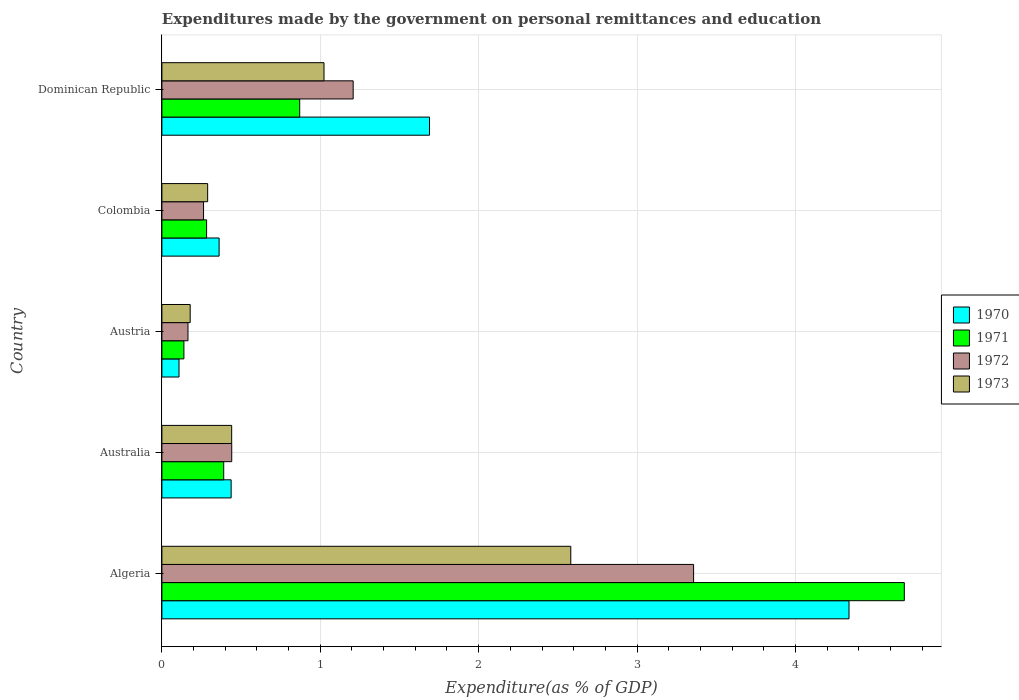How many different coloured bars are there?
Your response must be concise. 4. How many bars are there on the 3rd tick from the top?
Your answer should be very brief. 4. What is the label of the 2nd group of bars from the top?
Offer a terse response. Colombia. What is the expenditures made by the government on personal remittances and education in 1971 in Colombia?
Ensure brevity in your answer.  0.28. Across all countries, what is the maximum expenditures made by the government on personal remittances and education in 1973?
Offer a very short reply. 2.58. Across all countries, what is the minimum expenditures made by the government on personal remittances and education in 1972?
Your answer should be compact. 0.16. In which country was the expenditures made by the government on personal remittances and education in 1973 maximum?
Ensure brevity in your answer.  Algeria. What is the total expenditures made by the government on personal remittances and education in 1970 in the graph?
Make the answer very short. 6.93. What is the difference between the expenditures made by the government on personal remittances and education in 1972 in Colombia and that in Dominican Republic?
Your answer should be compact. -0.94. What is the difference between the expenditures made by the government on personal remittances and education in 1972 in Austria and the expenditures made by the government on personal remittances and education in 1971 in Colombia?
Offer a very short reply. -0.12. What is the average expenditures made by the government on personal remittances and education in 1971 per country?
Provide a succinct answer. 1.27. What is the difference between the expenditures made by the government on personal remittances and education in 1973 and expenditures made by the government on personal remittances and education in 1970 in Dominican Republic?
Provide a short and direct response. -0.67. What is the ratio of the expenditures made by the government on personal remittances and education in 1970 in Algeria to that in Dominican Republic?
Ensure brevity in your answer.  2.57. Is the difference between the expenditures made by the government on personal remittances and education in 1973 in Algeria and Austria greater than the difference between the expenditures made by the government on personal remittances and education in 1970 in Algeria and Austria?
Your answer should be compact. No. What is the difference between the highest and the second highest expenditures made by the government on personal remittances and education in 1972?
Your response must be concise. 2.15. What is the difference between the highest and the lowest expenditures made by the government on personal remittances and education in 1971?
Provide a short and direct response. 4.55. Is the sum of the expenditures made by the government on personal remittances and education in 1972 in Australia and Austria greater than the maximum expenditures made by the government on personal remittances and education in 1973 across all countries?
Offer a very short reply. No. Is it the case that in every country, the sum of the expenditures made by the government on personal remittances and education in 1973 and expenditures made by the government on personal remittances and education in 1970 is greater than the sum of expenditures made by the government on personal remittances and education in 1972 and expenditures made by the government on personal remittances and education in 1971?
Provide a short and direct response. No. What does the 3rd bar from the top in Algeria represents?
Provide a short and direct response. 1971. Are all the bars in the graph horizontal?
Offer a terse response. Yes. What is the difference between two consecutive major ticks on the X-axis?
Offer a very short reply. 1. Are the values on the major ticks of X-axis written in scientific E-notation?
Give a very brief answer. No. Does the graph contain grids?
Your answer should be very brief. Yes. How are the legend labels stacked?
Provide a short and direct response. Vertical. What is the title of the graph?
Keep it short and to the point. Expenditures made by the government on personal remittances and education. What is the label or title of the X-axis?
Provide a short and direct response. Expenditure(as % of GDP). What is the Expenditure(as % of GDP) in 1970 in Algeria?
Your response must be concise. 4.34. What is the Expenditure(as % of GDP) of 1971 in Algeria?
Your answer should be very brief. 4.69. What is the Expenditure(as % of GDP) in 1972 in Algeria?
Provide a short and direct response. 3.36. What is the Expenditure(as % of GDP) in 1973 in Algeria?
Provide a succinct answer. 2.58. What is the Expenditure(as % of GDP) of 1970 in Australia?
Provide a short and direct response. 0.44. What is the Expenditure(as % of GDP) of 1971 in Australia?
Give a very brief answer. 0.39. What is the Expenditure(as % of GDP) of 1972 in Australia?
Keep it short and to the point. 0.44. What is the Expenditure(as % of GDP) of 1973 in Australia?
Provide a succinct answer. 0.44. What is the Expenditure(as % of GDP) in 1970 in Austria?
Offer a very short reply. 0.11. What is the Expenditure(as % of GDP) in 1971 in Austria?
Ensure brevity in your answer.  0.14. What is the Expenditure(as % of GDP) of 1972 in Austria?
Offer a terse response. 0.16. What is the Expenditure(as % of GDP) of 1973 in Austria?
Keep it short and to the point. 0.18. What is the Expenditure(as % of GDP) of 1970 in Colombia?
Keep it short and to the point. 0.36. What is the Expenditure(as % of GDP) of 1971 in Colombia?
Offer a terse response. 0.28. What is the Expenditure(as % of GDP) of 1972 in Colombia?
Your answer should be very brief. 0.26. What is the Expenditure(as % of GDP) in 1973 in Colombia?
Offer a very short reply. 0.29. What is the Expenditure(as % of GDP) of 1970 in Dominican Republic?
Your answer should be compact. 1.69. What is the Expenditure(as % of GDP) of 1971 in Dominican Republic?
Keep it short and to the point. 0.87. What is the Expenditure(as % of GDP) in 1972 in Dominican Republic?
Make the answer very short. 1.21. What is the Expenditure(as % of GDP) in 1973 in Dominican Republic?
Keep it short and to the point. 1.02. Across all countries, what is the maximum Expenditure(as % of GDP) of 1970?
Provide a succinct answer. 4.34. Across all countries, what is the maximum Expenditure(as % of GDP) of 1971?
Keep it short and to the point. 4.69. Across all countries, what is the maximum Expenditure(as % of GDP) in 1972?
Make the answer very short. 3.36. Across all countries, what is the maximum Expenditure(as % of GDP) of 1973?
Offer a terse response. 2.58. Across all countries, what is the minimum Expenditure(as % of GDP) in 1970?
Keep it short and to the point. 0.11. Across all countries, what is the minimum Expenditure(as % of GDP) of 1971?
Offer a terse response. 0.14. Across all countries, what is the minimum Expenditure(as % of GDP) in 1972?
Offer a very short reply. 0.16. Across all countries, what is the minimum Expenditure(as % of GDP) of 1973?
Offer a terse response. 0.18. What is the total Expenditure(as % of GDP) in 1970 in the graph?
Provide a succinct answer. 6.93. What is the total Expenditure(as % of GDP) in 1971 in the graph?
Ensure brevity in your answer.  6.37. What is the total Expenditure(as % of GDP) in 1972 in the graph?
Give a very brief answer. 5.43. What is the total Expenditure(as % of GDP) of 1973 in the graph?
Your answer should be compact. 4.51. What is the difference between the Expenditure(as % of GDP) of 1970 in Algeria and that in Australia?
Give a very brief answer. 3.9. What is the difference between the Expenditure(as % of GDP) in 1971 in Algeria and that in Australia?
Provide a short and direct response. 4.3. What is the difference between the Expenditure(as % of GDP) in 1972 in Algeria and that in Australia?
Give a very brief answer. 2.92. What is the difference between the Expenditure(as % of GDP) in 1973 in Algeria and that in Australia?
Provide a succinct answer. 2.14. What is the difference between the Expenditure(as % of GDP) of 1970 in Algeria and that in Austria?
Your answer should be compact. 4.23. What is the difference between the Expenditure(as % of GDP) of 1971 in Algeria and that in Austria?
Ensure brevity in your answer.  4.55. What is the difference between the Expenditure(as % of GDP) in 1972 in Algeria and that in Austria?
Your response must be concise. 3.19. What is the difference between the Expenditure(as % of GDP) of 1973 in Algeria and that in Austria?
Provide a succinct answer. 2.4. What is the difference between the Expenditure(as % of GDP) in 1970 in Algeria and that in Colombia?
Give a very brief answer. 3.98. What is the difference between the Expenditure(as % of GDP) in 1971 in Algeria and that in Colombia?
Your response must be concise. 4.41. What is the difference between the Expenditure(as % of GDP) in 1972 in Algeria and that in Colombia?
Offer a very short reply. 3.09. What is the difference between the Expenditure(as % of GDP) of 1973 in Algeria and that in Colombia?
Offer a very short reply. 2.29. What is the difference between the Expenditure(as % of GDP) in 1970 in Algeria and that in Dominican Republic?
Your answer should be very brief. 2.65. What is the difference between the Expenditure(as % of GDP) of 1971 in Algeria and that in Dominican Republic?
Your response must be concise. 3.82. What is the difference between the Expenditure(as % of GDP) in 1972 in Algeria and that in Dominican Republic?
Keep it short and to the point. 2.15. What is the difference between the Expenditure(as % of GDP) of 1973 in Algeria and that in Dominican Republic?
Your answer should be very brief. 1.56. What is the difference between the Expenditure(as % of GDP) of 1970 in Australia and that in Austria?
Make the answer very short. 0.33. What is the difference between the Expenditure(as % of GDP) in 1971 in Australia and that in Austria?
Offer a very short reply. 0.25. What is the difference between the Expenditure(as % of GDP) in 1972 in Australia and that in Austria?
Your response must be concise. 0.28. What is the difference between the Expenditure(as % of GDP) of 1973 in Australia and that in Austria?
Give a very brief answer. 0.26. What is the difference between the Expenditure(as % of GDP) of 1970 in Australia and that in Colombia?
Give a very brief answer. 0.08. What is the difference between the Expenditure(as % of GDP) in 1971 in Australia and that in Colombia?
Provide a succinct answer. 0.11. What is the difference between the Expenditure(as % of GDP) of 1972 in Australia and that in Colombia?
Your response must be concise. 0.18. What is the difference between the Expenditure(as % of GDP) of 1973 in Australia and that in Colombia?
Your answer should be very brief. 0.15. What is the difference between the Expenditure(as % of GDP) of 1970 in Australia and that in Dominican Republic?
Your answer should be very brief. -1.25. What is the difference between the Expenditure(as % of GDP) in 1971 in Australia and that in Dominican Republic?
Give a very brief answer. -0.48. What is the difference between the Expenditure(as % of GDP) of 1972 in Australia and that in Dominican Republic?
Make the answer very short. -0.77. What is the difference between the Expenditure(as % of GDP) of 1973 in Australia and that in Dominican Republic?
Make the answer very short. -0.58. What is the difference between the Expenditure(as % of GDP) in 1970 in Austria and that in Colombia?
Offer a very short reply. -0.25. What is the difference between the Expenditure(as % of GDP) in 1971 in Austria and that in Colombia?
Give a very brief answer. -0.14. What is the difference between the Expenditure(as % of GDP) in 1972 in Austria and that in Colombia?
Your response must be concise. -0.1. What is the difference between the Expenditure(as % of GDP) in 1973 in Austria and that in Colombia?
Offer a very short reply. -0.11. What is the difference between the Expenditure(as % of GDP) of 1970 in Austria and that in Dominican Republic?
Make the answer very short. -1.58. What is the difference between the Expenditure(as % of GDP) in 1971 in Austria and that in Dominican Republic?
Offer a very short reply. -0.73. What is the difference between the Expenditure(as % of GDP) of 1972 in Austria and that in Dominican Republic?
Offer a very short reply. -1.04. What is the difference between the Expenditure(as % of GDP) in 1973 in Austria and that in Dominican Republic?
Offer a very short reply. -0.84. What is the difference between the Expenditure(as % of GDP) of 1970 in Colombia and that in Dominican Republic?
Ensure brevity in your answer.  -1.33. What is the difference between the Expenditure(as % of GDP) of 1971 in Colombia and that in Dominican Republic?
Offer a very short reply. -0.59. What is the difference between the Expenditure(as % of GDP) of 1972 in Colombia and that in Dominican Republic?
Offer a very short reply. -0.94. What is the difference between the Expenditure(as % of GDP) of 1973 in Colombia and that in Dominican Republic?
Your answer should be compact. -0.73. What is the difference between the Expenditure(as % of GDP) in 1970 in Algeria and the Expenditure(as % of GDP) in 1971 in Australia?
Provide a short and direct response. 3.95. What is the difference between the Expenditure(as % of GDP) of 1970 in Algeria and the Expenditure(as % of GDP) of 1972 in Australia?
Provide a succinct answer. 3.9. What is the difference between the Expenditure(as % of GDP) of 1970 in Algeria and the Expenditure(as % of GDP) of 1973 in Australia?
Keep it short and to the point. 3.9. What is the difference between the Expenditure(as % of GDP) of 1971 in Algeria and the Expenditure(as % of GDP) of 1972 in Australia?
Your answer should be very brief. 4.25. What is the difference between the Expenditure(as % of GDP) in 1971 in Algeria and the Expenditure(as % of GDP) in 1973 in Australia?
Your answer should be very brief. 4.25. What is the difference between the Expenditure(as % of GDP) of 1972 in Algeria and the Expenditure(as % of GDP) of 1973 in Australia?
Offer a very short reply. 2.92. What is the difference between the Expenditure(as % of GDP) of 1970 in Algeria and the Expenditure(as % of GDP) of 1971 in Austria?
Keep it short and to the point. 4.2. What is the difference between the Expenditure(as % of GDP) in 1970 in Algeria and the Expenditure(as % of GDP) in 1972 in Austria?
Your answer should be very brief. 4.17. What is the difference between the Expenditure(as % of GDP) in 1970 in Algeria and the Expenditure(as % of GDP) in 1973 in Austria?
Provide a succinct answer. 4.16. What is the difference between the Expenditure(as % of GDP) of 1971 in Algeria and the Expenditure(as % of GDP) of 1972 in Austria?
Make the answer very short. 4.52. What is the difference between the Expenditure(as % of GDP) of 1971 in Algeria and the Expenditure(as % of GDP) of 1973 in Austria?
Provide a short and direct response. 4.51. What is the difference between the Expenditure(as % of GDP) in 1972 in Algeria and the Expenditure(as % of GDP) in 1973 in Austria?
Your answer should be very brief. 3.18. What is the difference between the Expenditure(as % of GDP) of 1970 in Algeria and the Expenditure(as % of GDP) of 1971 in Colombia?
Ensure brevity in your answer.  4.06. What is the difference between the Expenditure(as % of GDP) of 1970 in Algeria and the Expenditure(as % of GDP) of 1972 in Colombia?
Your answer should be very brief. 4.08. What is the difference between the Expenditure(as % of GDP) of 1970 in Algeria and the Expenditure(as % of GDP) of 1973 in Colombia?
Ensure brevity in your answer.  4.05. What is the difference between the Expenditure(as % of GDP) in 1971 in Algeria and the Expenditure(as % of GDP) in 1972 in Colombia?
Offer a terse response. 4.42. What is the difference between the Expenditure(as % of GDP) of 1971 in Algeria and the Expenditure(as % of GDP) of 1973 in Colombia?
Your answer should be compact. 4.4. What is the difference between the Expenditure(as % of GDP) in 1972 in Algeria and the Expenditure(as % of GDP) in 1973 in Colombia?
Offer a very short reply. 3.07. What is the difference between the Expenditure(as % of GDP) in 1970 in Algeria and the Expenditure(as % of GDP) in 1971 in Dominican Republic?
Your answer should be compact. 3.47. What is the difference between the Expenditure(as % of GDP) in 1970 in Algeria and the Expenditure(as % of GDP) in 1972 in Dominican Republic?
Your response must be concise. 3.13. What is the difference between the Expenditure(as % of GDP) in 1970 in Algeria and the Expenditure(as % of GDP) in 1973 in Dominican Republic?
Keep it short and to the point. 3.31. What is the difference between the Expenditure(as % of GDP) in 1971 in Algeria and the Expenditure(as % of GDP) in 1972 in Dominican Republic?
Provide a short and direct response. 3.48. What is the difference between the Expenditure(as % of GDP) in 1971 in Algeria and the Expenditure(as % of GDP) in 1973 in Dominican Republic?
Make the answer very short. 3.66. What is the difference between the Expenditure(as % of GDP) of 1972 in Algeria and the Expenditure(as % of GDP) of 1973 in Dominican Republic?
Provide a succinct answer. 2.33. What is the difference between the Expenditure(as % of GDP) of 1970 in Australia and the Expenditure(as % of GDP) of 1971 in Austria?
Ensure brevity in your answer.  0.3. What is the difference between the Expenditure(as % of GDP) in 1970 in Australia and the Expenditure(as % of GDP) in 1972 in Austria?
Offer a terse response. 0.27. What is the difference between the Expenditure(as % of GDP) in 1970 in Australia and the Expenditure(as % of GDP) in 1973 in Austria?
Provide a short and direct response. 0.26. What is the difference between the Expenditure(as % of GDP) of 1971 in Australia and the Expenditure(as % of GDP) of 1972 in Austria?
Ensure brevity in your answer.  0.23. What is the difference between the Expenditure(as % of GDP) of 1971 in Australia and the Expenditure(as % of GDP) of 1973 in Austria?
Provide a short and direct response. 0.21. What is the difference between the Expenditure(as % of GDP) of 1972 in Australia and the Expenditure(as % of GDP) of 1973 in Austria?
Provide a succinct answer. 0.26. What is the difference between the Expenditure(as % of GDP) of 1970 in Australia and the Expenditure(as % of GDP) of 1971 in Colombia?
Your answer should be very brief. 0.15. What is the difference between the Expenditure(as % of GDP) of 1970 in Australia and the Expenditure(as % of GDP) of 1972 in Colombia?
Make the answer very short. 0.17. What is the difference between the Expenditure(as % of GDP) of 1970 in Australia and the Expenditure(as % of GDP) of 1973 in Colombia?
Make the answer very short. 0.15. What is the difference between the Expenditure(as % of GDP) in 1971 in Australia and the Expenditure(as % of GDP) in 1972 in Colombia?
Make the answer very short. 0.13. What is the difference between the Expenditure(as % of GDP) in 1971 in Australia and the Expenditure(as % of GDP) in 1973 in Colombia?
Make the answer very short. 0.1. What is the difference between the Expenditure(as % of GDP) of 1972 in Australia and the Expenditure(as % of GDP) of 1973 in Colombia?
Your answer should be compact. 0.15. What is the difference between the Expenditure(as % of GDP) of 1970 in Australia and the Expenditure(as % of GDP) of 1971 in Dominican Republic?
Provide a succinct answer. -0.43. What is the difference between the Expenditure(as % of GDP) in 1970 in Australia and the Expenditure(as % of GDP) in 1972 in Dominican Republic?
Offer a very short reply. -0.77. What is the difference between the Expenditure(as % of GDP) in 1970 in Australia and the Expenditure(as % of GDP) in 1973 in Dominican Republic?
Your answer should be very brief. -0.59. What is the difference between the Expenditure(as % of GDP) in 1971 in Australia and the Expenditure(as % of GDP) in 1972 in Dominican Republic?
Make the answer very short. -0.82. What is the difference between the Expenditure(as % of GDP) in 1971 in Australia and the Expenditure(as % of GDP) in 1973 in Dominican Republic?
Your answer should be compact. -0.63. What is the difference between the Expenditure(as % of GDP) of 1972 in Australia and the Expenditure(as % of GDP) of 1973 in Dominican Republic?
Offer a terse response. -0.58. What is the difference between the Expenditure(as % of GDP) in 1970 in Austria and the Expenditure(as % of GDP) in 1971 in Colombia?
Give a very brief answer. -0.17. What is the difference between the Expenditure(as % of GDP) of 1970 in Austria and the Expenditure(as % of GDP) of 1972 in Colombia?
Your response must be concise. -0.15. What is the difference between the Expenditure(as % of GDP) in 1970 in Austria and the Expenditure(as % of GDP) in 1973 in Colombia?
Provide a succinct answer. -0.18. What is the difference between the Expenditure(as % of GDP) in 1971 in Austria and the Expenditure(as % of GDP) in 1972 in Colombia?
Ensure brevity in your answer.  -0.12. What is the difference between the Expenditure(as % of GDP) of 1971 in Austria and the Expenditure(as % of GDP) of 1973 in Colombia?
Offer a very short reply. -0.15. What is the difference between the Expenditure(as % of GDP) of 1972 in Austria and the Expenditure(as % of GDP) of 1973 in Colombia?
Keep it short and to the point. -0.12. What is the difference between the Expenditure(as % of GDP) in 1970 in Austria and the Expenditure(as % of GDP) in 1971 in Dominican Republic?
Provide a short and direct response. -0.76. What is the difference between the Expenditure(as % of GDP) of 1970 in Austria and the Expenditure(as % of GDP) of 1972 in Dominican Republic?
Ensure brevity in your answer.  -1.1. What is the difference between the Expenditure(as % of GDP) in 1970 in Austria and the Expenditure(as % of GDP) in 1973 in Dominican Republic?
Make the answer very short. -0.92. What is the difference between the Expenditure(as % of GDP) of 1971 in Austria and the Expenditure(as % of GDP) of 1972 in Dominican Republic?
Your answer should be compact. -1.07. What is the difference between the Expenditure(as % of GDP) of 1971 in Austria and the Expenditure(as % of GDP) of 1973 in Dominican Republic?
Ensure brevity in your answer.  -0.88. What is the difference between the Expenditure(as % of GDP) in 1972 in Austria and the Expenditure(as % of GDP) in 1973 in Dominican Republic?
Offer a very short reply. -0.86. What is the difference between the Expenditure(as % of GDP) in 1970 in Colombia and the Expenditure(as % of GDP) in 1971 in Dominican Republic?
Ensure brevity in your answer.  -0.51. What is the difference between the Expenditure(as % of GDP) of 1970 in Colombia and the Expenditure(as % of GDP) of 1972 in Dominican Republic?
Your answer should be very brief. -0.85. What is the difference between the Expenditure(as % of GDP) in 1970 in Colombia and the Expenditure(as % of GDP) in 1973 in Dominican Republic?
Keep it short and to the point. -0.66. What is the difference between the Expenditure(as % of GDP) of 1971 in Colombia and the Expenditure(as % of GDP) of 1972 in Dominican Republic?
Make the answer very short. -0.93. What is the difference between the Expenditure(as % of GDP) in 1971 in Colombia and the Expenditure(as % of GDP) in 1973 in Dominican Republic?
Make the answer very short. -0.74. What is the difference between the Expenditure(as % of GDP) in 1972 in Colombia and the Expenditure(as % of GDP) in 1973 in Dominican Republic?
Provide a succinct answer. -0.76. What is the average Expenditure(as % of GDP) in 1970 per country?
Provide a short and direct response. 1.39. What is the average Expenditure(as % of GDP) in 1971 per country?
Offer a terse response. 1.27. What is the average Expenditure(as % of GDP) in 1972 per country?
Your response must be concise. 1.09. What is the average Expenditure(as % of GDP) of 1973 per country?
Offer a terse response. 0.9. What is the difference between the Expenditure(as % of GDP) in 1970 and Expenditure(as % of GDP) in 1971 in Algeria?
Offer a very short reply. -0.35. What is the difference between the Expenditure(as % of GDP) in 1970 and Expenditure(as % of GDP) in 1972 in Algeria?
Provide a short and direct response. 0.98. What is the difference between the Expenditure(as % of GDP) of 1970 and Expenditure(as % of GDP) of 1973 in Algeria?
Ensure brevity in your answer.  1.76. What is the difference between the Expenditure(as % of GDP) in 1971 and Expenditure(as % of GDP) in 1972 in Algeria?
Ensure brevity in your answer.  1.33. What is the difference between the Expenditure(as % of GDP) of 1971 and Expenditure(as % of GDP) of 1973 in Algeria?
Ensure brevity in your answer.  2.11. What is the difference between the Expenditure(as % of GDP) in 1972 and Expenditure(as % of GDP) in 1973 in Algeria?
Provide a short and direct response. 0.78. What is the difference between the Expenditure(as % of GDP) of 1970 and Expenditure(as % of GDP) of 1971 in Australia?
Your response must be concise. 0.05. What is the difference between the Expenditure(as % of GDP) in 1970 and Expenditure(as % of GDP) in 1972 in Australia?
Keep it short and to the point. -0. What is the difference between the Expenditure(as % of GDP) in 1970 and Expenditure(as % of GDP) in 1973 in Australia?
Offer a very short reply. -0. What is the difference between the Expenditure(as % of GDP) in 1971 and Expenditure(as % of GDP) in 1972 in Australia?
Provide a succinct answer. -0.05. What is the difference between the Expenditure(as % of GDP) in 1971 and Expenditure(as % of GDP) in 1973 in Australia?
Keep it short and to the point. -0.05. What is the difference between the Expenditure(as % of GDP) in 1972 and Expenditure(as % of GDP) in 1973 in Australia?
Give a very brief answer. 0. What is the difference between the Expenditure(as % of GDP) in 1970 and Expenditure(as % of GDP) in 1971 in Austria?
Ensure brevity in your answer.  -0.03. What is the difference between the Expenditure(as % of GDP) in 1970 and Expenditure(as % of GDP) in 1972 in Austria?
Ensure brevity in your answer.  -0.06. What is the difference between the Expenditure(as % of GDP) in 1970 and Expenditure(as % of GDP) in 1973 in Austria?
Provide a succinct answer. -0.07. What is the difference between the Expenditure(as % of GDP) in 1971 and Expenditure(as % of GDP) in 1972 in Austria?
Keep it short and to the point. -0.03. What is the difference between the Expenditure(as % of GDP) of 1971 and Expenditure(as % of GDP) of 1973 in Austria?
Make the answer very short. -0.04. What is the difference between the Expenditure(as % of GDP) in 1972 and Expenditure(as % of GDP) in 1973 in Austria?
Ensure brevity in your answer.  -0.01. What is the difference between the Expenditure(as % of GDP) in 1970 and Expenditure(as % of GDP) in 1971 in Colombia?
Your answer should be compact. 0.08. What is the difference between the Expenditure(as % of GDP) of 1970 and Expenditure(as % of GDP) of 1972 in Colombia?
Your answer should be compact. 0.1. What is the difference between the Expenditure(as % of GDP) in 1970 and Expenditure(as % of GDP) in 1973 in Colombia?
Your response must be concise. 0.07. What is the difference between the Expenditure(as % of GDP) in 1971 and Expenditure(as % of GDP) in 1972 in Colombia?
Your answer should be very brief. 0.02. What is the difference between the Expenditure(as % of GDP) of 1971 and Expenditure(as % of GDP) of 1973 in Colombia?
Keep it short and to the point. -0.01. What is the difference between the Expenditure(as % of GDP) in 1972 and Expenditure(as % of GDP) in 1973 in Colombia?
Provide a short and direct response. -0.03. What is the difference between the Expenditure(as % of GDP) of 1970 and Expenditure(as % of GDP) of 1971 in Dominican Republic?
Your answer should be very brief. 0.82. What is the difference between the Expenditure(as % of GDP) of 1970 and Expenditure(as % of GDP) of 1972 in Dominican Republic?
Provide a short and direct response. 0.48. What is the difference between the Expenditure(as % of GDP) of 1970 and Expenditure(as % of GDP) of 1973 in Dominican Republic?
Make the answer very short. 0.67. What is the difference between the Expenditure(as % of GDP) in 1971 and Expenditure(as % of GDP) in 1972 in Dominican Republic?
Provide a short and direct response. -0.34. What is the difference between the Expenditure(as % of GDP) of 1971 and Expenditure(as % of GDP) of 1973 in Dominican Republic?
Offer a terse response. -0.15. What is the difference between the Expenditure(as % of GDP) in 1972 and Expenditure(as % of GDP) in 1973 in Dominican Republic?
Your answer should be compact. 0.18. What is the ratio of the Expenditure(as % of GDP) in 1970 in Algeria to that in Australia?
Offer a terse response. 9.92. What is the ratio of the Expenditure(as % of GDP) of 1971 in Algeria to that in Australia?
Ensure brevity in your answer.  12.01. What is the ratio of the Expenditure(as % of GDP) of 1972 in Algeria to that in Australia?
Your answer should be very brief. 7.61. What is the ratio of the Expenditure(as % of GDP) in 1973 in Algeria to that in Australia?
Your answer should be very brief. 5.86. What is the ratio of the Expenditure(as % of GDP) of 1970 in Algeria to that in Austria?
Keep it short and to the point. 40.14. What is the ratio of the Expenditure(as % of GDP) in 1971 in Algeria to that in Austria?
Give a very brief answer. 33.73. What is the ratio of the Expenditure(as % of GDP) of 1972 in Algeria to that in Austria?
Offer a very short reply. 20.38. What is the ratio of the Expenditure(as % of GDP) in 1973 in Algeria to that in Austria?
Keep it short and to the point. 14.45. What is the ratio of the Expenditure(as % of GDP) of 1970 in Algeria to that in Colombia?
Ensure brevity in your answer.  12.01. What is the ratio of the Expenditure(as % of GDP) of 1971 in Algeria to that in Colombia?
Your response must be concise. 16.61. What is the ratio of the Expenditure(as % of GDP) in 1972 in Algeria to that in Colombia?
Offer a terse response. 12.77. What is the ratio of the Expenditure(as % of GDP) in 1973 in Algeria to that in Colombia?
Offer a very short reply. 8.94. What is the ratio of the Expenditure(as % of GDP) in 1970 in Algeria to that in Dominican Republic?
Keep it short and to the point. 2.57. What is the ratio of the Expenditure(as % of GDP) of 1971 in Algeria to that in Dominican Republic?
Offer a very short reply. 5.39. What is the ratio of the Expenditure(as % of GDP) in 1972 in Algeria to that in Dominican Republic?
Provide a succinct answer. 2.78. What is the ratio of the Expenditure(as % of GDP) of 1973 in Algeria to that in Dominican Republic?
Your answer should be very brief. 2.52. What is the ratio of the Expenditure(as % of GDP) in 1970 in Australia to that in Austria?
Provide a succinct answer. 4.04. What is the ratio of the Expenditure(as % of GDP) in 1971 in Australia to that in Austria?
Provide a short and direct response. 2.81. What is the ratio of the Expenditure(as % of GDP) of 1972 in Australia to that in Austria?
Offer a very short reply. 2.68. What is the ratio of the Expenditure(as % of GDP) of 1973 in Australia to that in Austria?
Provide a succinct answer. 2.47. What is the ratio of the Expenditure(as % of GDP) in 1970 in Australia to that in Colombia?
Your answer should be compact. 1.21. What is the ratio of the Expenditure(as % of GDP) of 1971 in Australia to that in Colombia?
Ensure brevity in your answer.  1.38. What is the ratio of the Expenditure(as % of GDP) in 1972 in Australia to that in Colombia?
Ensure brevity in your answer.  1.68. What is the ratio of the Expenditure(as % of GDP) of 1973 in Australia to that in Colombia?
Your answer should be compact. 1.52. What is the ratio of the Expenditure(as % of GDP) of 1970 in Australia to that in Dominican Republic?
Your answer should be compact. 0.26. What is the ratio of the Expenditure(as % of GDP) in 1971 in Australia to that in Dominican Republic?
Your answer should be compact. 0.45. What is the ratio of the Expenditure(as % of GDP) of 1972 in Australia to that in Dominican Republic?
Provide a succinct answer. 0.37. What is the ratio of the Expenditure(as % of GDP) in 1973 in Australia to that in Dominican Republic?
Your response must be concise. 0.43. What is the ratio of the Expenditure(as % of GDP) in 1970 in Austria to that in Colombia?
Your answer should be compact. 0.3. What is the ratio of the Expenditure(as % of GDP) of 1971 in Austria to that in Colombia?
Make the answer very short. 0.49. What is the ratio of the Expenditure(as % of GDP) of 1972 in Austria to that in Colombia?
Offer a terse response. 0.63. What is the ratio of the Expenditure(as % of GDP) of 1973 in Austria to that in Colombia?
Your answer should be very brief. 0.62. What is the ratio of the Expenditure(as % of GDP) of 1970 in Austria to that in Dominican Republic?
Offer a terse response. 0.06. What is the ratio of the Expenditure(as % of GDP) in 1971 in Austria to that in Dominican Republic?
Your answer should be very brief. 0.16. What is the ratio of the Expenditure(as % of GDP) of 1972 in Austria to that in Dominican Republic?
Your response must be concise. 0.14. What is the ratio of the Expenditure(as % of GDP) in 1973 in Austria to that in Dominican Republic?
Offer a terse response. 0.17. What is the ratio of the Expenditure(as % of GDP) of 1970 in Colombia to that in Dominican Republic?
Offer a terse response. 0.21. What is the ratio of the Expenditure(as % of GDP) in 1971 in Colombia to that in Dominican Republic?
Give a very brief answer. 0.32. What is the ratio of the Expenditure(as % of GDP) in 1972 in Colombia to that in Dominican Republic?
Offer a terse response. 0.22. What is the ratio of the Expenditure(as % of GDP) of 1973 in Colombia to that in Dominican Republic?
Your answer should be very brief. 0.28. What is the difference between the highest and the second highest Expenditure(as % of GDP) in 1970?
Your answer should be very brief. 2.65. What is the difference between the highest and the second highest Expenditure(as % of GDP) in 1971?
Your answer should be compact. 3.82. What is the difference between the highest and the second highest Expenditure(as % of GDP) of 1972?
Offer a terse response. 2.15. What is the difference between the highest and the second highest Expenditure(as % of GDP) in 1973?
Offer a very short reply. 1.56. What is the difference between the highest and the lowest Expenditure(as % of GDP) of 1970?
Your response must be concise. 4.23. What is the difference between the highest and the lowest Expenditure(as % of GDP) of 1971?
Offer a terse response. 4.55. What is the difference between the highest and the lowest Expenditure(as % of GDP) in 1972?
Provide a succinct answer. 3.19. What is the difference between the highest and the lowest Expenditure(as % of GDP) in 1973?
Provide a succinct answer. 2.4. 